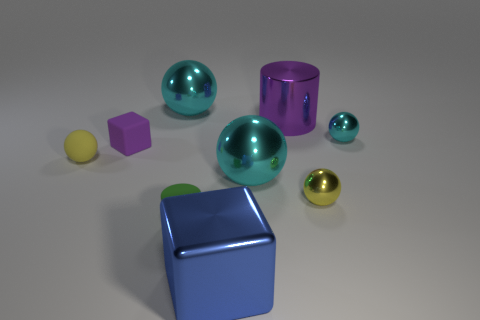There is a small yellow thing left of the small yellow sphere on the right side of the big purple cylinder; what is it made of?
Make the answer very short. Rubber. Are there an equal number of small matte objects behind the big shiny cylinder and big spheres that are on the right side of the big blue object?
Your answer should be very brief. No. What number of objects are balls left of the yellow metallic sphere or cyan spheres that are to the right of the tiny yellow shiny thing?
Ensure brevity in your answer.  4. There is a ball that is both on the left side of the green cylinder and in front of the purple rubber thing; what material is it?
Keep it short and to the point. Rubber. What size is the purple matte thing on the left side of the cylinder in front of the big cyan ball that is in front of the tiny cyan ball?
Give a very brief answer. Small. Is the number of small yellow metallic spheres greater than the number of big cyan metallic objects?
Give a very brief answer. No. Does the small yellow sphere to the right of the large blue metallic block have the same material as the green thing?
Your answer should be very brief. No. Are there fewer small shiny balls than brown rubber balls?
Offer a terse response. No. Are there any big cylinders that are to the left of the big blue metal thing in front of the small yellow sphere on the right side of the purple shiny cylinder?
Keep it short and to the point. No. There is a cyan shiny object left of the green object; is its shape the same as the green thing?
Your answer should be compact. No. 